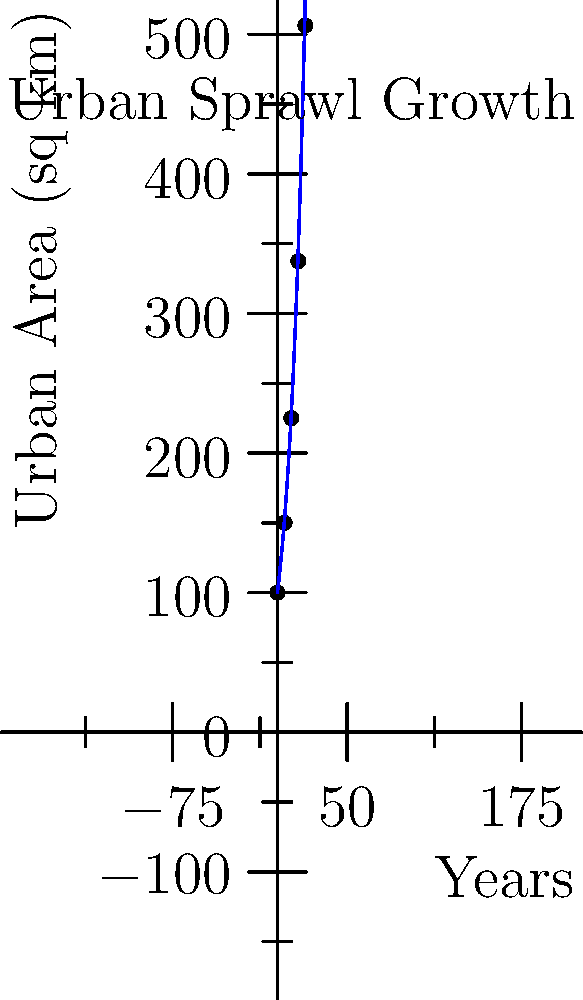The graph above shows the exponential growth of urban area over a 20-year period in a rapidly developing region. Given this trend, calculate the projected urban area after 25 years. How might this impact real estate investment strategies, particularly in areas adjacent to the expanding urban boundary? To solve this problem and understand its implications for real estate investment, let's follow these steps:

1. Identify the growth pattern:
   The graph shows an exponential growth curve for urban area over time.

2. Determine the mathematical model:
   The general form of exponential growth is $A(t) = A_0 * e^{rt}$, where:
   $A(t)$ is the area at time $t$
   $A_0$ is the initial area
   $r$ is the growth rate
   $t$ is the time

3. Find the parameters:
   $A_0 = 100$ sq km (initial area at t=0)
   At t=20 years, $A(20) = 506.25$ sq km

4. Calculate the growth rate:
   $506.25 = 100 * e^{20r}$
   $ln(5.0625) = 20r$
   $r = ln(5.0625) / 20 ≈ 0.0832$

5. Use the model to project area at 25 years:
   $A(25) = 100 * e^{0.0832 * 25} ≈ 782.04$ sq km

6. Implications for real estate investment:
   a) Increased demand for land in expanding areas
   b) Potential for higher returns on investments in periphery zones
   c) Opportunities for development of new residential and commercial properties
   d) Possible infrastructure challenges and associated investment opportunities
   e) Risk of overextension and potential for localized market saturation

7. Investment strategies:
   a) Focus on acquiring land in the path of expansion
   b) Develop properties that cater to suburban lifestyles
   c) Invest in mixed-use developments to capitalize on new community needs
   d) Consider potential for future rezoning and increased property values
   e) Be aware of potential regulatory changes that may affect urban sprawl
Answer: 782.04 sq km; invest in peripheral areas with potential for rezoning and development. 